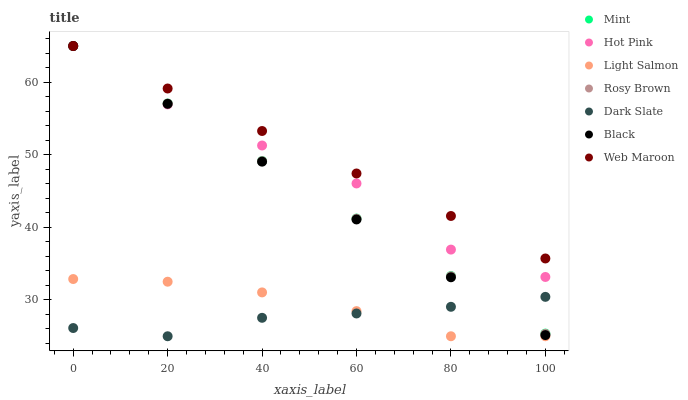Does Dark Slate have the minimum area under the curve?
Answer yes or no. Yes. Does Web Maroon have the maximum area under the curve?
Answer yes or no. Yes. Does Rosy Brown have the minimum area under the curve?
Answer yes or no. No. Does Rosy Brown have the maximum area under the curve?
Answer yes or no. No. Is Black the smoothest?
Answer yes or no. Yes. Is Hot Pink the roughest?
Answer yes or no. Yes. Is Rosy Brown the smoothest?
Answer yes or no. No. Is Rosy Brown the roughest?
Answer yes or no. No. Does Light Salmon have the lowest value?
Answer yes or no. Yes. Does Rosy Brown have the lowest value?
Answer yes or no. No. Does Mint have the highest value?
Answer yes or no. Yes. Does Dark Slate have the highest value?
Answer yes or no. No. Is Light Salmon less than Hot Pink?
Answer yes or no. Yes. Is Hot Pink greater than Dark Slate?
Answer yes or no. Yes. Does Mint intersect Web Maroon?
Answer yes or no. Yes. Is Mint less than Web Maroon?
Answer yes or no. No. Is Mint greater than Web Maroon?
Answer yes or no. No. Does Light Salmon intersect Hot Pink?
Answer yes or no. No. 